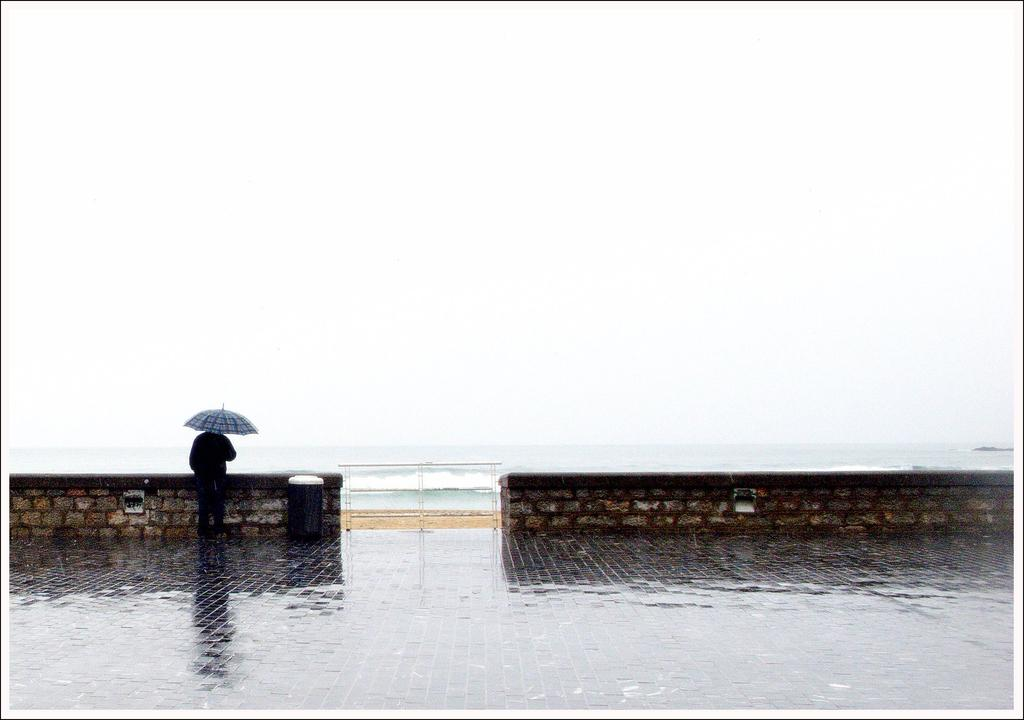What is the person in the image doing? The person is standing in the image and holding an umbrella. What can be seen in the background of the image? The background of the image includes the sea, the sky, walls with cobblestones, and a bin. What might the person be using the umbrella for? The person might be using the umbrella to protect themselves from rain or sun. What is the person feeling in the image? The image does not provide information about the person's emotions, so we cannot determine how they are feeling. 